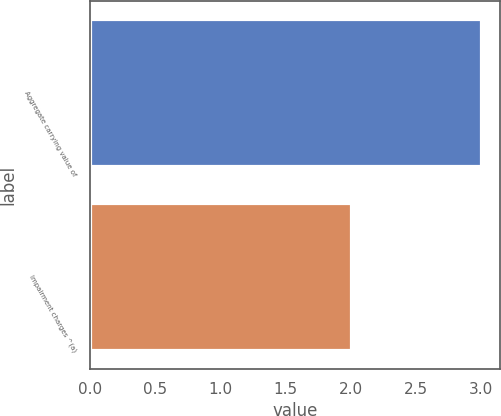<chart> <loc_0><loc_0><loc_500><loc_500><bar_chart><fcel>Aggregate carrying value of<fcel>Impairment charges ^(a)<nl><fcel>3<fcel>2<nl></chart> 